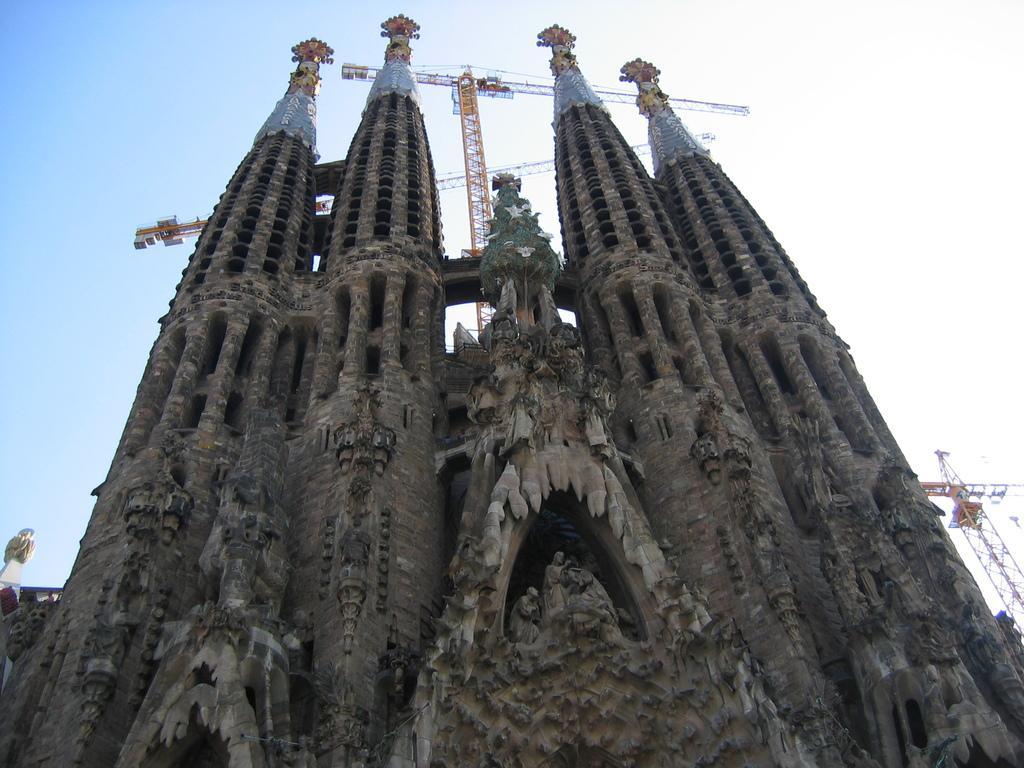In one or two sentences, can you explain what this image depicts? In this image I can see towers, sculptures of a person and metal rods. In the background I can see the blue sky. This image is taken may be during a day. 